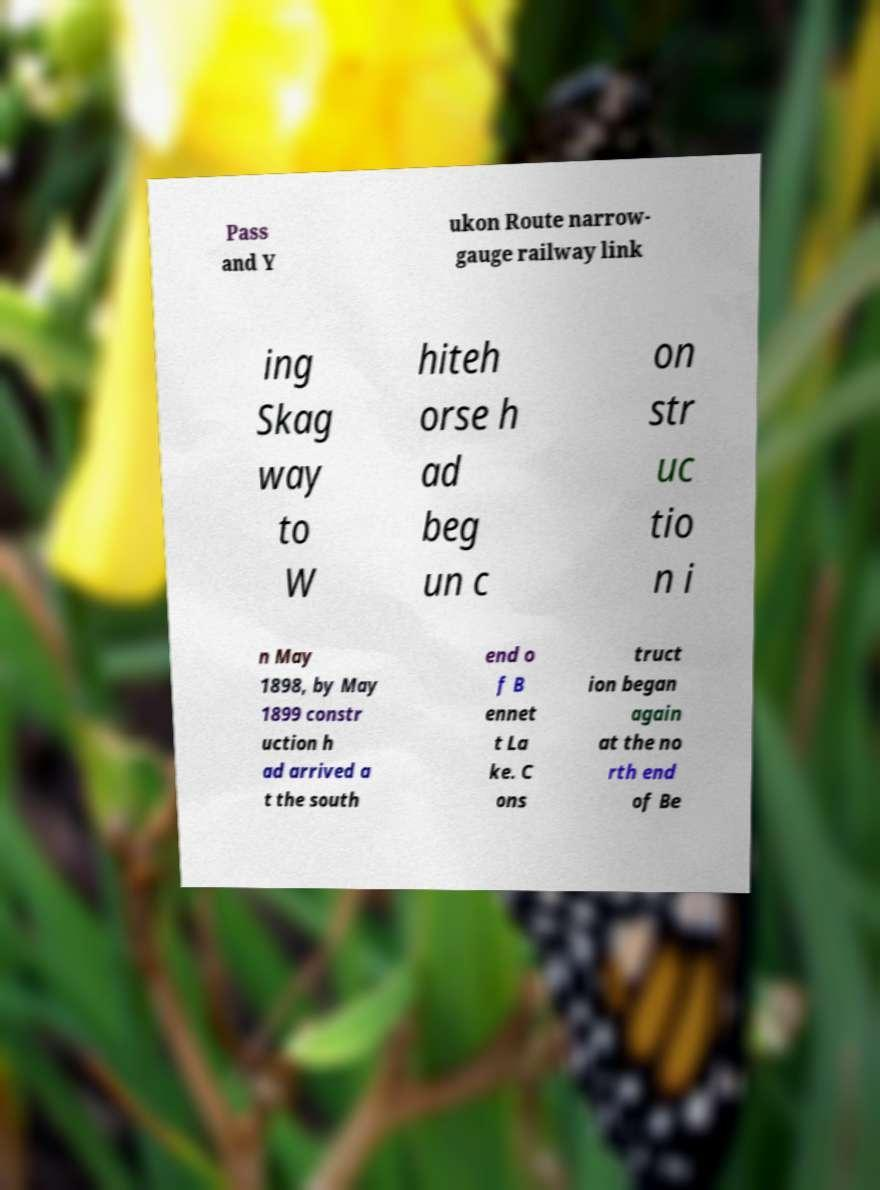Please read and relay the text visible in this image. What does it say? Pass and Y ukon Route narrow- gauge railway link ing Skag way to W hiteh orse h ad beg un c on str uc tio n i n May 1898, by May 1899 constr uction h ad arrived a t the south end o f B ennet t La ke. C ons truct ion began again at the no rth end of Be 